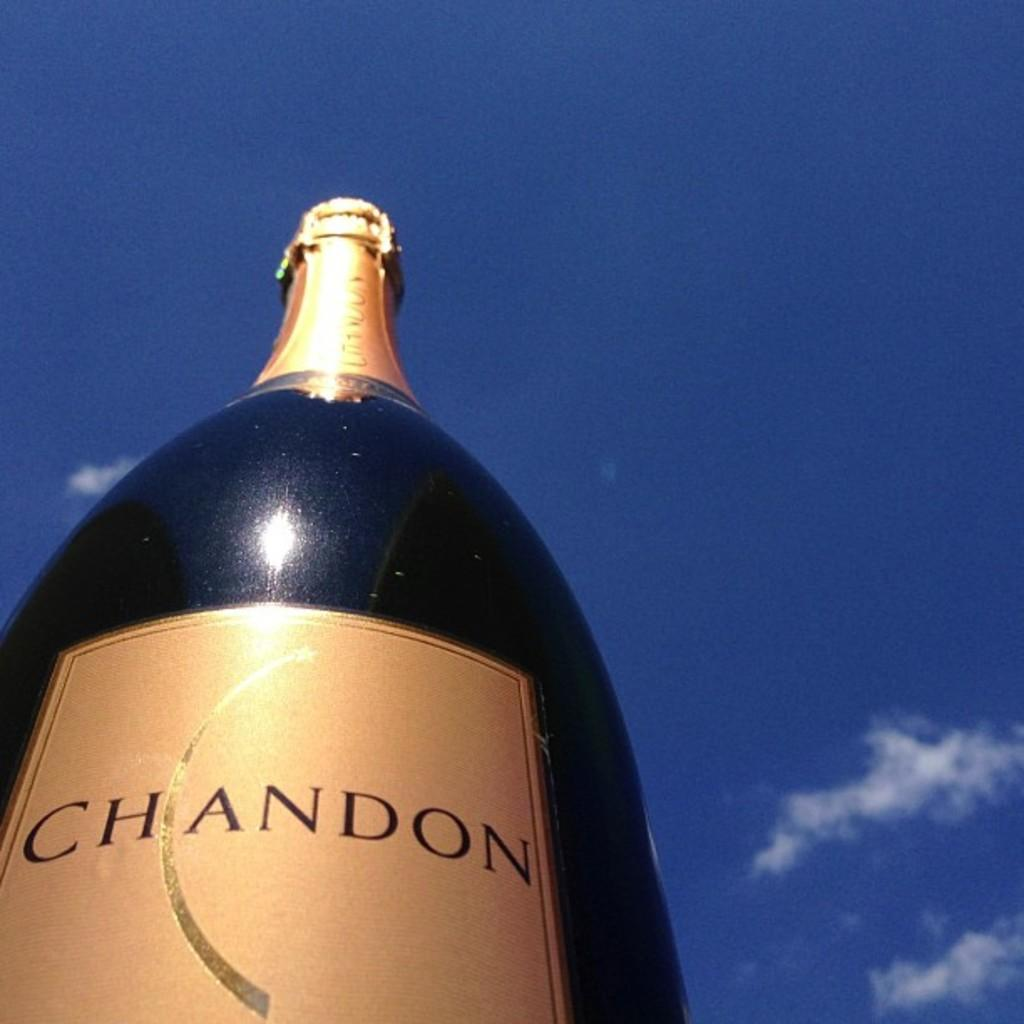What object is located in the bottom left corner of the image? There is a bottle in the bottom left corner of the image. What can be seen in the sky at the top of the image? There are clouds in the sky at the top of the image. Where is the car parked in the image? There is no car present in the image. Is there a volcano visible in the image? No, there is no volcano present in the image. 